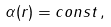Convert formula to latex. <formula><loc_0><loc_0><loc_500><loc_500>\alpha ( r ) = c o n s t \, ,</formula> 